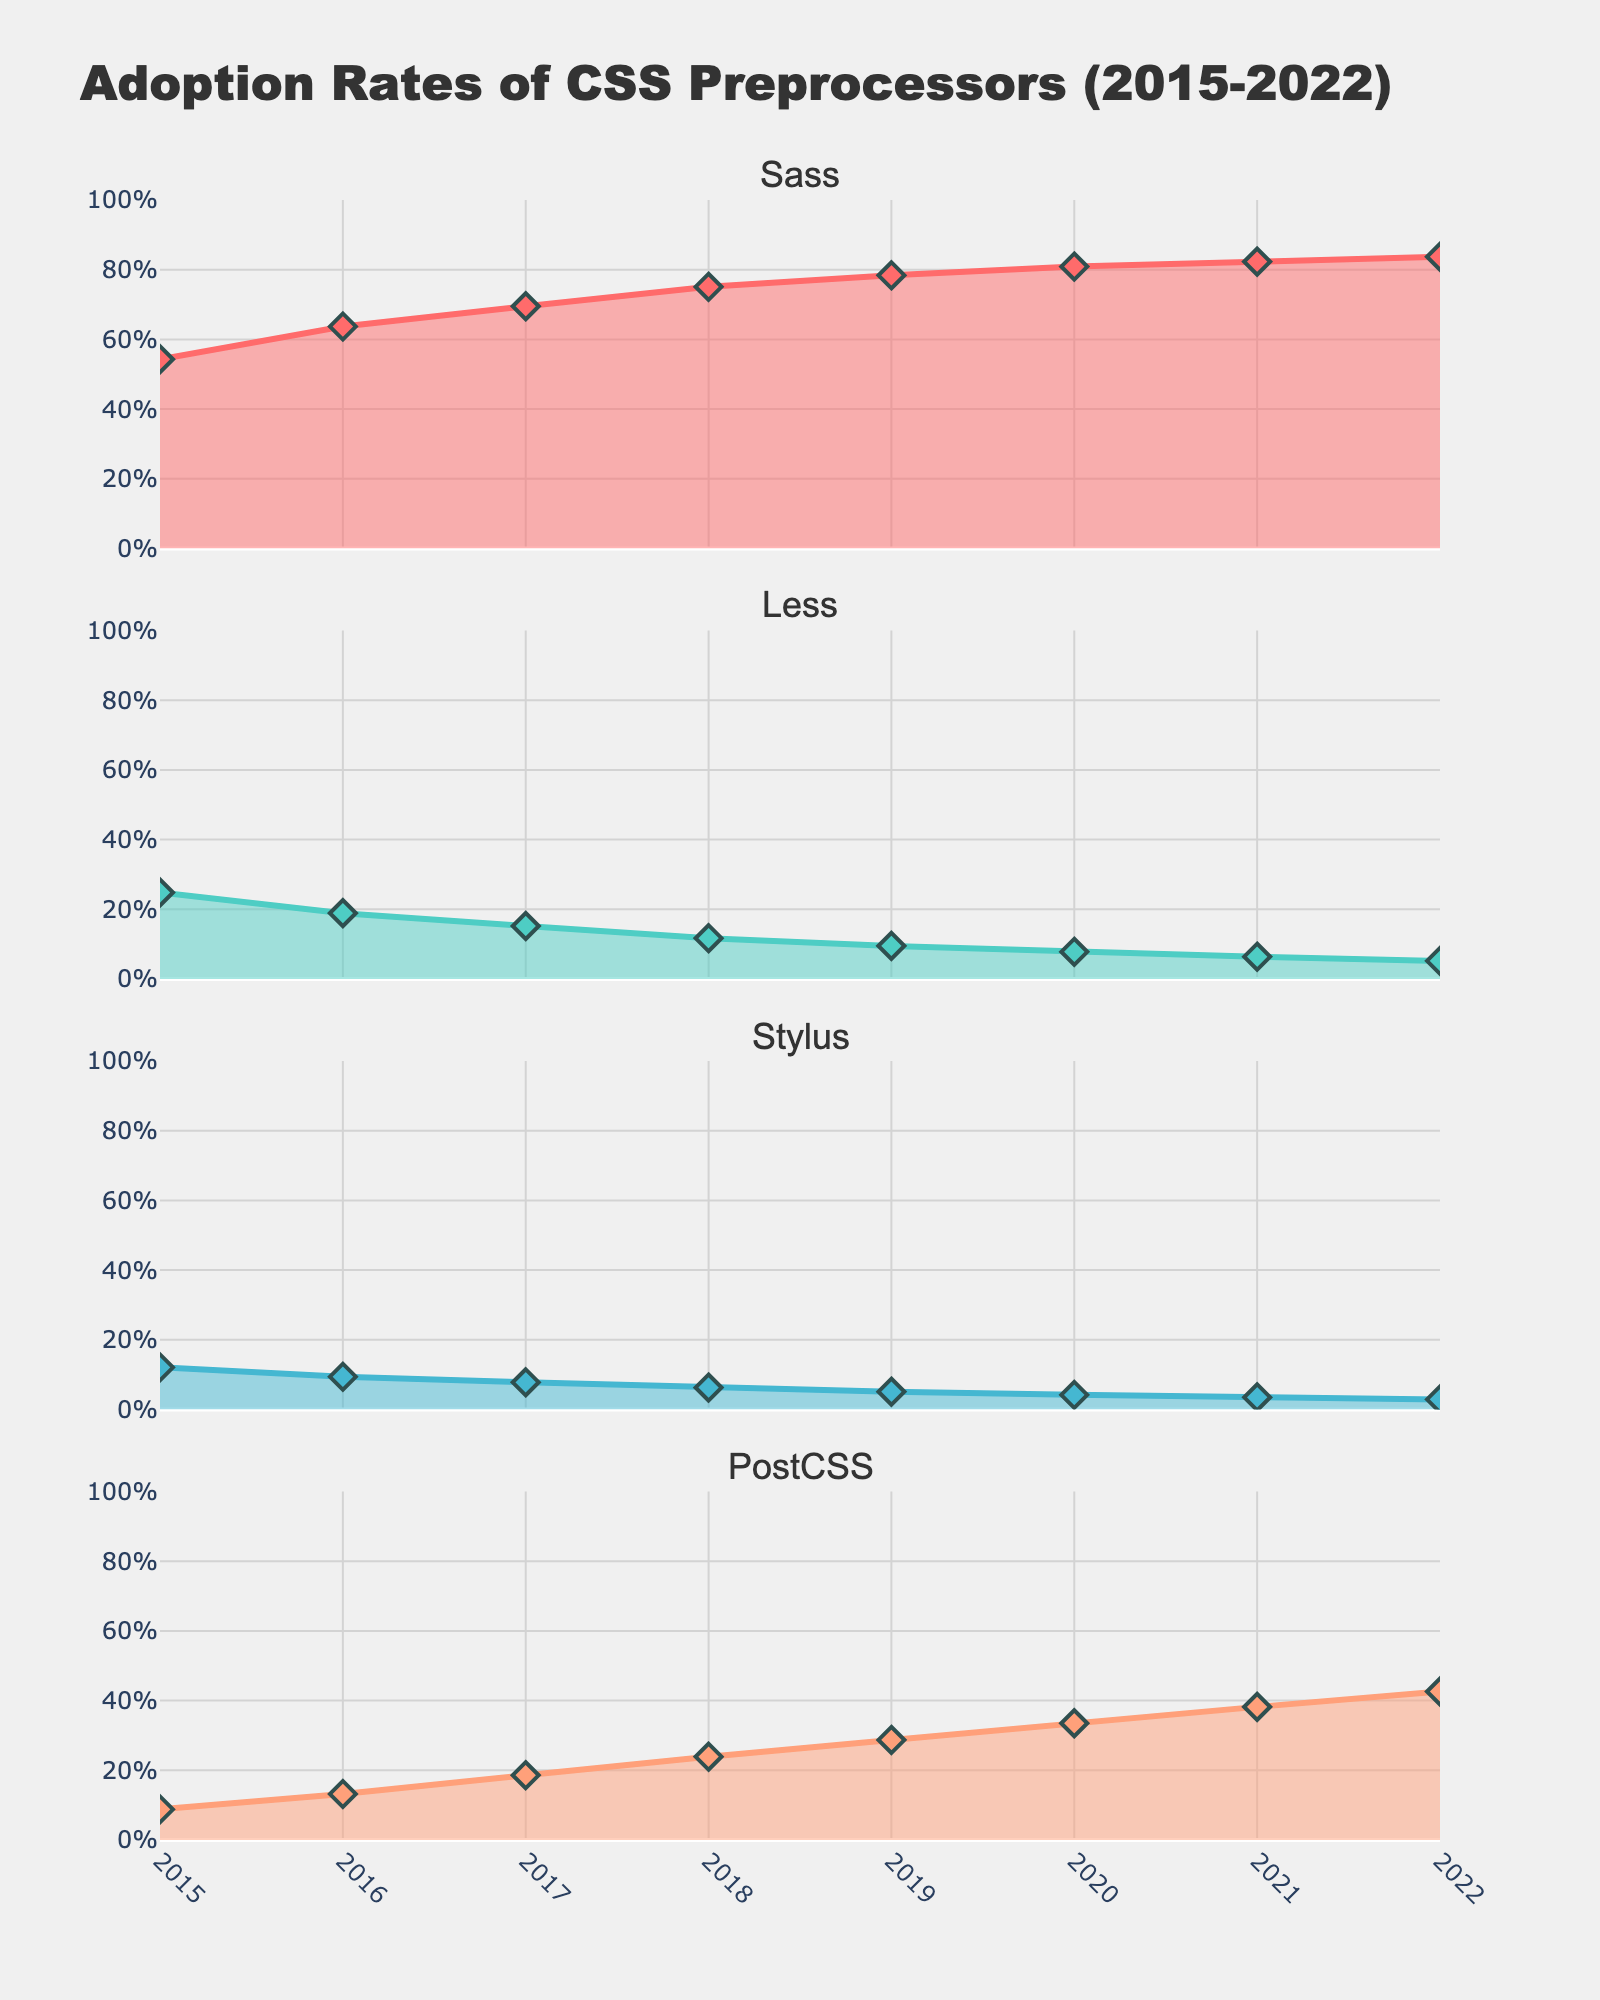What's the title of the figure? The title is displayed at the top of the figure, it reads "Evolution of R&B Chart Performance (1970-2020)."
Answer: Evolution of R&B Chart Performance (1970-2020) Which artist had the longest-lasting number-one hit in the 1970s? In the subplot for the 1970s, the bar with the highest "Weeks at #1" is "Lean on Me" by Bill Withers with 3 weeks.
Answer: Bill Withers How many songs are shown for each decade? Each decade subplot in the figure contains bars for 5 songs, each representing a different decade from 1970s to 2010s.
Answer: 5 Compare the longest-lasting number-one hits of the 1980s and 2000s. Which one lasted longer? From the subplots, the longest-lasting hit in the 1980s is "Sexual Healing" by Marvin Gaye with 10 weeks, while in the 2000s it's "Be Without You" by Mary J. Blige with 15 weeks. Therefore, the 2000s' longest-lasting hit lasted longer.
Answer: 2000s What's the sum of the weeks at number one for the top 10 songs in the 1990s? Summing the "Weeks at #1" for the top 10 songs in the 1990s subplot: 14 + 13 + 14 + 11 + 7 = 59 weeks.
Answer: 59 What is the average number of weeks at number one for the top 10 songs in the 2000s? Calculate the average by summing the weeks (15 + 10 + 14 + 12 + 7 = 58) and dividing by 5, the number of songs: 58 / 5 = 11.6 weeks.
Answer: 11.6 Which song by Bruno Mars is listed in the 2010s subplot and how many weeks did it stay at number one? The figure shows "Uptown Funk" by Mark Ronson featuring Bruno Mars which lasted for 14 weeks and "That's What I Like" by Bruno Mars which lasted for 1 week.
Answer: Uptown Funk, 14 weeks; That's What I Like, 1 week Which song from the 1990s had the longest run at number one and how long was it? In the 1990s subplot, the song with the longest duration at number one is "I'll Make Love to You" by Boyz II Men with 14 weeks.
Answer: I'll Make Love to You, 14 weeks What's the total number of weeks at number one for the songs by Boyz II Men in the 1990s? Sum the "Weeks at #1" for Boyz II Men’s songs in the 1990s: "End of the Road" (13 weeks) and "I'll Make Love to You" (14 weeks); 13 + 14 = 27 weeks.
Answer: 27 Among the listed songs, which artist appears in both the 1970s and the 1980s subplots? Marvin Gaye appears in both the 1970s with "Let's Get It On" and the 1980s with "Sexual Healing."
Answer: Marvin Gaye 